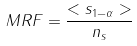Convert formula to latex. <formula><loc_0><loc_0><loc_500><loc_500>M R F = \frac { < s _ { 1 - \alpha } > } { n _ { s } }</formula> 